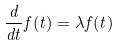Convert formula to latex. <formula><loc_0><loc_0><loc_500><loc_500>\frac { d } { d t } f ( t ) = \lambda f ( t )</formula> 